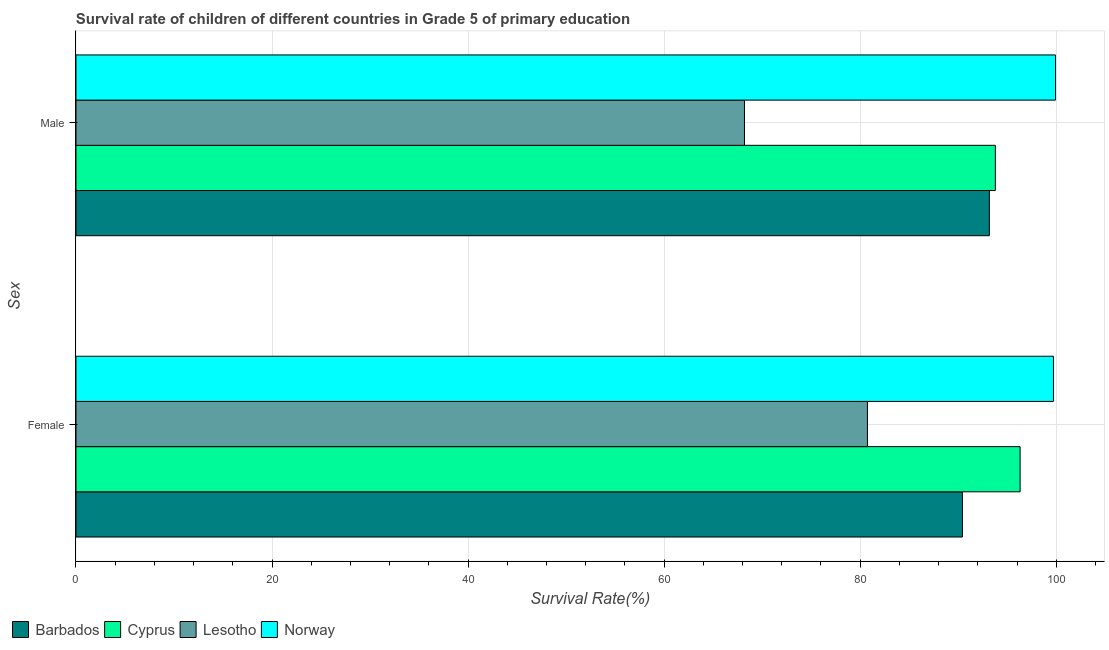How many different coloured bars are there?
Offer a terse response. 4. Are the number of bars on each tick of the Y-axis equal?
Make the answer very short. Yes. How many bars are there on the 2nd tick from the top?
Give a very brief answer. 4. How many bars are there on the 2nd tick from the bottom?
Provide a succinct answer. 4. What is the survival rate of female students in primary education in Lesotho?
Your answer should be compact. 80.74. Across all countries, what is the maximum survival rate of female students in primary education?
Offer a very short reply. 99.71. Across all countries, what is the minimum survival rate of male students in primary education?
Offer a very short reply. 68.19. In which country was the survival rate of female students in primary education maximum?
Give a very brief answer. Norway. In which country was the survival rate of male students in primary education minimum?
Provide a short and direct response. Lesotho. What is the total survival rate of female students in primary education in the graph?
Your response must be concise. 367.19. What is the difference between the survival rate of male students in primary education in Barbados and that in Norway?
Provide a succinct answer. -6.75. What is the difference between the survival rate of male students in primary education in Barbados and the survival rate of female students in primary education in Cyprus?
Your answer should be compact. -3.14. What is the average survival rate of male students in primary education per country?
Ensure brevity in your answer.  88.77. What is the difference between the survival rate of female students in primary education and survival rate of male students in primary education in Cyprus?
Give a very brief answer. 2.53. In how many countries, is the survival rate of male students in primary education greater than 44 %?
Make the answer very short. 4. What is the ratio of the survival rate of male students in primary education in Cyprus to that in Barbados?
Make the answer very short. 1.01. Is the survival rate of male students in primary education in Cyprus less than that in Barbados?
Ensure brevity in your answer.  No. What does the 3rd bar from the top in Male represents?
Your answer should be very brief. Cyprus. What does the 2nd bar from the bottom in Female represents?
Offer a terse response. Cyprus. How many countries are there in the graph?
Your answer should be compact. 4. What is the difference between two consecutive major ticks on the X-axis?
Provide a succinct answer. 20. Are the values on the major ticks of X-axis written in scientific E-notation?
Ensure brevity in your answer.  No. Does the graph contain grids?
Make the answer very short. Yes. How many legend labels are there?
Provide a short and direct response. 4. What is the title of the graph?
Your answer should be compact. Survival rate of children of different countries in Grade 5 of primary education. Does "Liberia" appear as one of the legend labels in the graph?
Provide a succinct answer. No. What is the label or title of the X-axis?
Offer a terse response. Survival Rate(%). What is the label or title of the Y-axis?
Keep it short and to the point. Sex. What is the Survival Rate(%) of Barbados in Female?
Provide a succinct answer. 90.43. What is the Survival Rate(%) of Cyprus in Female?
Make the answer very short. 96.31. What is the Survival Rate(%) of Lesotho in Female?
Offer a terse response. 80.74. What is the Survival Rate(%) in Norway in Female?
Offer a terse response. 99.71. What is the Survival Rate(%) of Barbados in Male?
Make the answer very short. 93.18. What is the Survival Rate(%) of Cyprus in Male?
Your response must be concise. 93.79. What is the Survival Rate(%) in Lesotho in Male?
Ensure brevity in your answer.  68.19. What is the Survival Rate(%) in Norway in Male?
Provide a succinct answer. 99.92. Across all Sex, what is the maximum Survival Rate(%) of Barbados?
Offer a terse response. 93.18. Across all Sex, what is the maximum Survival Rate(%) in Cyprus?
Your answer should be compact. 96.31. Across all Sex, what is the maximum Survival Rate(%) in Lesotho?
Provide a succinct answer. 80.74. Across all Sex, what is the maximum Survival Rate(%) in Norway?
Your response must be concise. 99.92. Across all Sex, what is the minimum Survival Rate(%) of Barbados?
Keep it short and to the point. 90.43. Across all Sex, what is the minimum Survival Rate(%) of Cyprus?
Your response must be concise. 93.79. Across all Sex, what is the minimum Survival Rate(%) in Lesotho?
Keep it short and to the point. 68.19. Across all Sex, what is the minimum Survival Rate(%) in Norway?
Offer a very short reply. 99.71. What is the total Survival Rate(%) of Barbados in the graph?
Make the answer very short. 183.6. What is the total Survival Rate(%) in Cyprus in the graph?
Your response must be concise. 190.1. What is the total Survival Rate(%) in Lesotho in the graph?
Provide a succinct answer. 148.93. What is the total Survival Rate(%) of Norway in the graph?
Provide a succinct answer. 199.64. What is the difference between the Survival Rate(%) of Barbados in Female and that in Male?
Your answer should be compact. -2.75. What is the difference between the Survival Rate(%) in Cyprus in Female and that in Male?
Offer a terse response. 2.53. What is the difference between the Survival Rate(%) of Lesotho in Female and that in Male?
Your answer should be very brief. 12.54. What is the difference between the Survival Rate(%) in Norway in Female and that in Male?
Ensure brevity in your answer.  -0.21. What is the difference between the Survival Rate(%) in Barbados in Female and the Survival Rate(%) in Cyprus in Male?
Your response must be concise. -3.36. What is the difference between the Survival Rate(%) of Barbados in Female and the Survival Rate(%) of Lesotho in Male?
Your answer should be compact. 22.23. What is the difference between the Survival Rate(%) of Barbados in Female and the Survival Rate(%) of Norway in Male?
Ensure brevity in your answer.  -9.5. What is the difference between the Survival Rate(%) in Cyprus in Female and the Survival Rate(%) in Lesotho in Male?
Ensure brevity in your answer.  28.12. What is the difference between the Survival Rate(%) of Cyprus in Female and the Survival Rate(%) of Norway in Male?
Your answer should be compact. -3.61. What is the difference between the Survival Rate(%) in Lesotho in Female and the Survival Rate(%) in Norway in Male?
Offer a very short reply. -19.19. What is the average Survival Rate(%) of Barbados per Sex?
Your answer should be compact. 91.8. What is the average Survival Rate(%) in Cyprus per Sex?
Offer a terse response. 95.05. What is the average Survival Rate(%) in Lesotho per Sex?
Offer a very short reply. 74.47. What is the average Survival Rate(%) in Norway per Sex?
Provide a succinct answer. 99.82. What is the difference between the Survival Rate(%) in Barbados and Survival Rate(%) in Cyprus in Female?
Your answer should be very brief. -5.88. What is the difference between the Survival Rate(%) in Barbados and Survival Rate(%) in Lesotho in Female?
Make the answer very short. 9.69. What is the difference between the Survival Rate(%) in Barbados and Survival Rate(%) in Norway in Female?
Give a very brief answer. -9.29. What is the difference between the Survival Rate(%) of Cyprus and Survival Rate(%) of Lesotho in Female?
Make the answer very short. 15.57. What is the difference between the Survival Rate(%) in Cyprus and Survival Rate(%) in Norway in Female?
Offer a very short reply. -3.4. What is the difference between the Survival Rate(%) of Lesotho and Survival Rate(%) of Norway in Female?
Provide a succinct answer. -18.98. What is the difference between the Survival Rate(%) in Barbados and Survival Rate(%) in Cyprus in Male?
Provide a short and direct response. -0.61. What is the difference between the Survival Rate(%) in Barbados and Survival Rate(%) in Lesotho in Male?
Your response must be concise. 24.98. What is the difference between the Survival Rate(%) of Barbados and Survival Rate(%) of Norway in Male?
Provide a succinct answer. -6.75. What is the difference between the Survival Rate(%) of Cyprus and Survival Rate(%) of Lesotho in Male?
Your response must be concise. 25.59. What is the difference between the Survival Rate(%) of Cyprus and Survival Rate(%) of Norway in Male?
Ensure brevity in your answer.  -6.14. What is the difference between the Survival Rate(%) in Lesotho and Survival Rate(%) in Norway in Male?
Offer a terse response. -31.73. What is the ratio of the Survival Rate(%) of Barbados in Female to that in Male?
Ensure brevity in your answer.  0.97. What is the ratio of the Survival Rate(%) of Cyprus in Female to that in Male?
Give a very brief answer. 1.03. What is the ratio of the Survival Rate(%) of Lesotho in Female to that in Male?
Ensure brevity in your answer.  1.18. What is the difference between the highest and the second highest Survival Rate(%) in Barbados?
Your response must be concise. 2.75. What is the difference between the highest and the second highest Survival Rate(%) of Cyprus?
Your answer should be very brief. 2.53. What is the difference between the highest and the second highest Survival Rate(%) in Lesotho?
Offer a very short reply. 12.54. What is the difference between the highest and the second highest Survival Rate(%) in Norway?
Your answer should be compact. 0.21. What is the difference between the highest and the lowest Survival Rate(%) in Barbados?
Make the answer very short. 2.75. What is the difference between the highest and the lowest Survival Rate(%) in Cyprus?
Your answer should be compact. 2.53. What is the difference between the highest and the lowest Survival Rate(%) in Lesotho?
Provide a succinct answer. 12.54. What is the difference between the highest and the lowest Survival Rate(%) of Norway?
Make the answer very short. 0.21. 